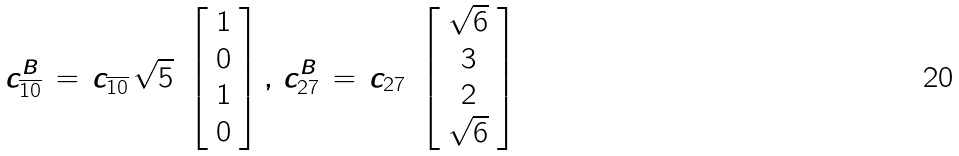<formula> <loc_0><loc_0><loc_500><loc_500>c ^ { B } _ { \overline { 1 0 } } \, = \, c _ { \overline { 1 0 } } \, \sqrt { 5 } \ \left [ \begin{array} { c } 1 \\ 0 \\ 1 \\ 0 \end{array} \right ] , \, c ^ { B } _ { 2 7 } \, = \, c _ { 2 7 } \ \left [ \begin{array} { c } \sqrt { 6 } \\ 3 \\ 2 \\ \sqrt { 6 } \end{array} \right ]</formula> 